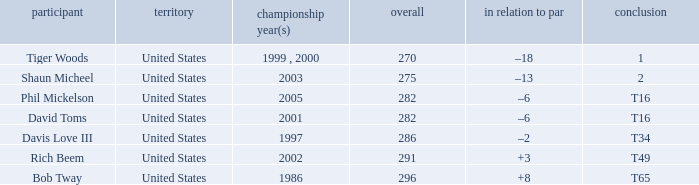In which year(s) did the person with a total greater than 286 win? 2002, 1986. 